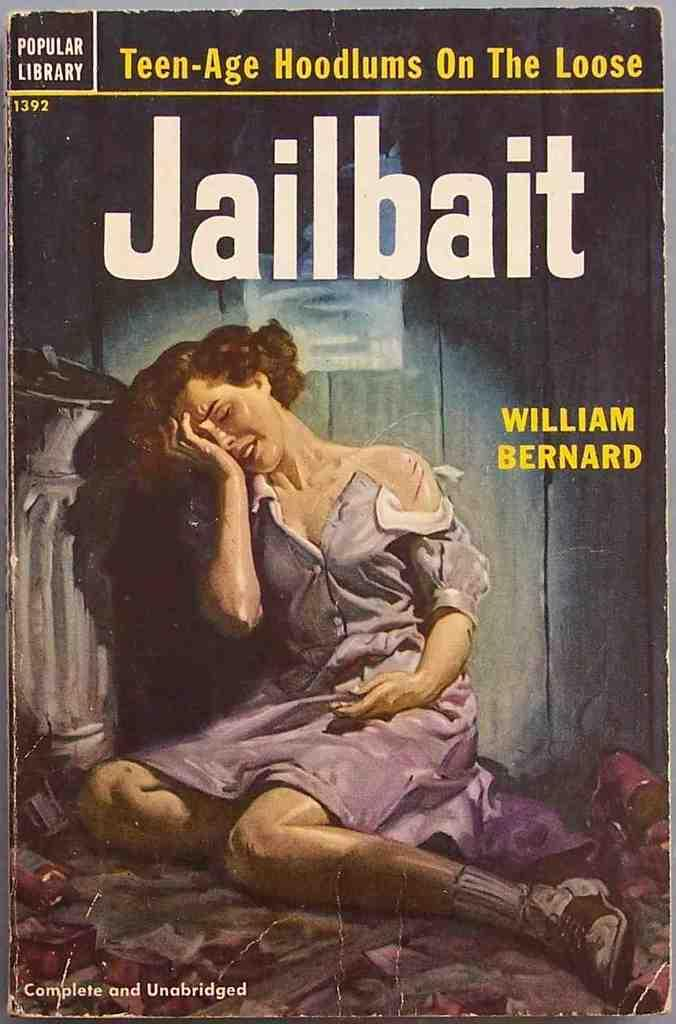<image>
Present a compact description of the photo's key features. Cover of a book titled "Jailbait" by William Bernard showing a woman crying. 